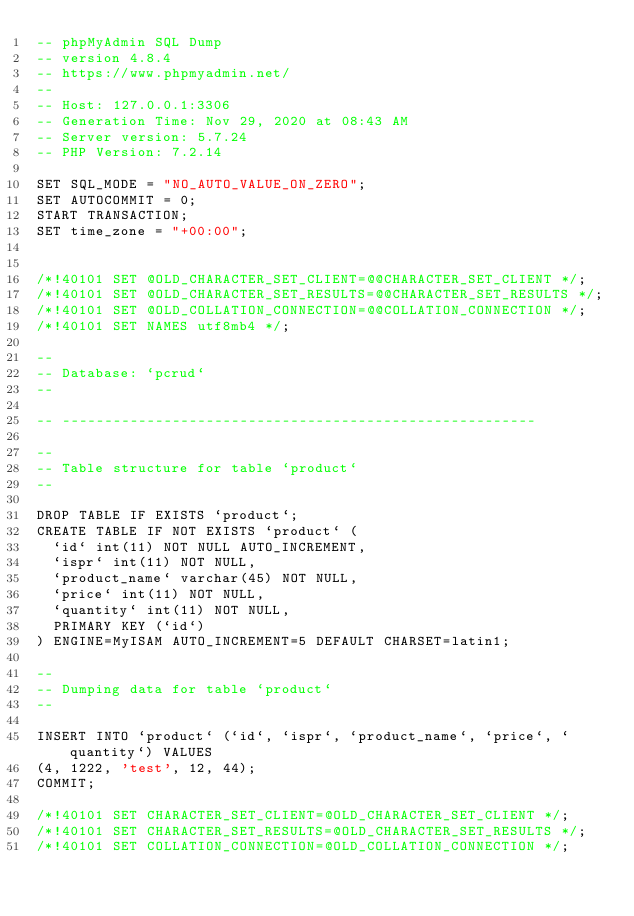Convert code to text. <code><loc_0><loc_0><loc_500><loc_500><_SQL_>-- phpMyAdmin SQL Dump
-- version 4.8.4
-- https://www.phpmyadmin.net/
--
-- Host: 127.0.0.1:3306
-- Generation Time: Nov 29, 2020 at 08:43 AM
-- Server version: 5.7.24
-- PHP Version: 7.2.14

SET SQL_MODE = "NO_AUTO_VALUE_ON_ZERO";
SET AUTOCOMMIT = 0;
START TRANSACTION;
SET time_zone = "+00:00";


/*!40101 SET @OLD_CHARACTER_SET_CLIENT=@@CHARACTER_SET_CLIENT */;
/*!40101 SET @OLD_CHARACTER_SET_RESULTS=@@CHARACTER_SET_RESULTS */;
/*!40101 SET @OLD_COLLATION_CONNECTION=@@COLLATION_CONNECTION */;
/*!40101 SET NAMES utf8mb4 */;

--
-- Database: `pcrud`
--

-- --------------------------------------------------------

--
-- Table structure for table `product`
--

DROP TABLE IF EXISTS `product`;
CREATE TABLE IF NOT EXISTS `product` (
  `id` int(11) NOT NULL AUTO_INCREMENT,
  `ispr` int(11) NOT NULL,
  `product_name` varchar(45) NOT NULL,
  `price` int(11) NOT NULL,
  `quantity` int(11) NOT NULL,
  PRIMARY KEY (`id`)
) ENGINE=MyISAM AUTO_INCREMENT=5 DEFAULT CHARSET=latin1;

--
-- Dumping data for table `product`
--

INSERT INTO `product` (`id`, `ispr`, `product_name`, `price`, `quantity`) VALUES
(4, 1222, 'test', 12, 44);
COMMIT;

/*!40101 SET CHARACTER_SET_CLIENT=@OLD_CHARACTER_SET_CLIENT */;
/*!40101 SET CHARACTER_SET_RESULTS=@OLD_CHARACTER_SET_RESULTS */;
/*!40101 SET COLLATION_CONNECTION=@OLD_COLLATION_CONNECTION */;
</code> 